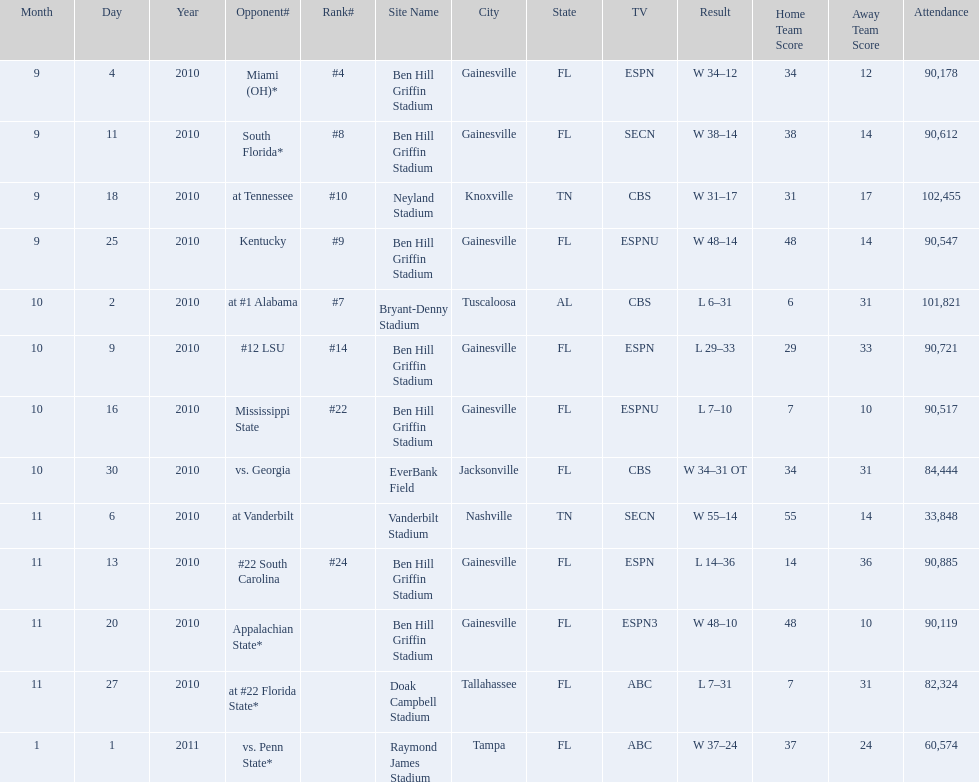What was the most the university of florida won by? 41 points. 